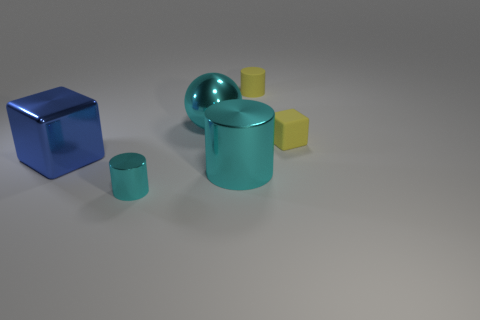Subtract all small cylinders. How many cylinders are left? 1 Subtract all blue cubes. How many cubes are left? 1 Add 4 blocks. How many objects exist? 10 Subtract all green cylinders. Subtract all yellow spheres. How many cylinders are left? 3 Subtract all cyan balls. How many purple cubes are left? 0 Subtract all tiny brown blocks. Subtract all small yellow matte things. How many objects are left? 4 Add 3 spheres. How many spheres are left? 4 Add 5 metallic things. How many metallic things exist? 9 Subtract 0 purple cylinders. How many objects are left? 6 Subtract all spheres. How many objects are left? 5 